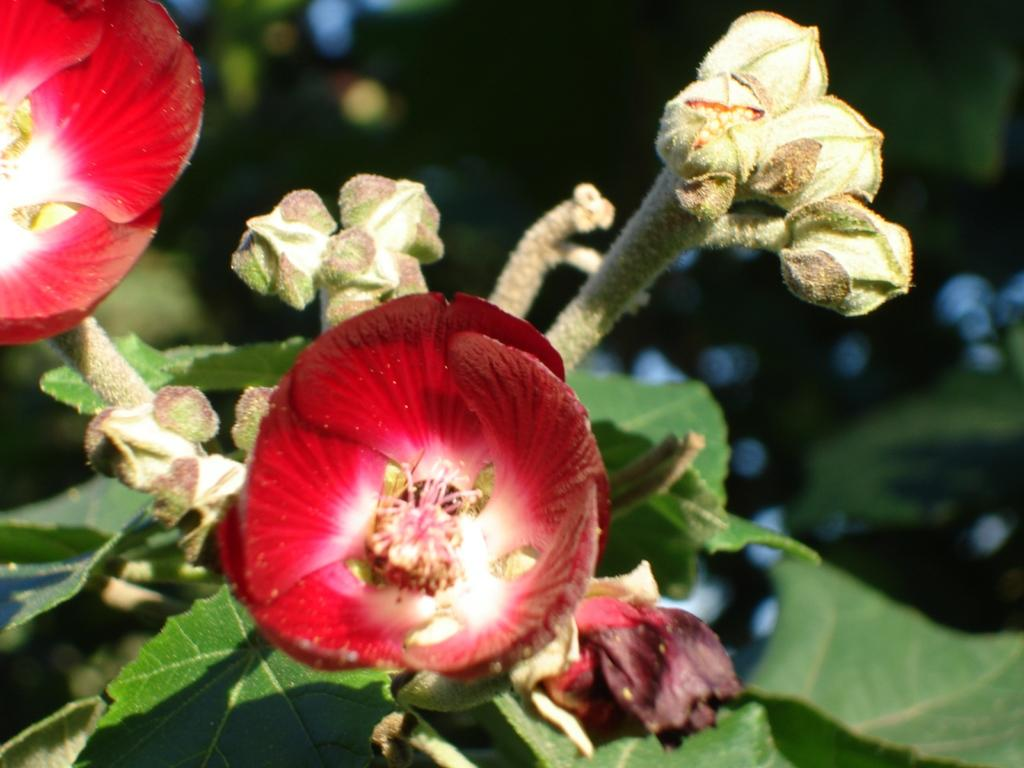What type of plants can be seen in the image? There are flowers, buds, and leaves in the image. Can you describe the stage of growth for the plants in the image? The plants in the image have both buds and flowers, indicating that they are in various stages of growth. What is the background of the image like? The background of the image is blurry. How many boys are playing the guitar in the image? There are no boys or guitars present in the image; it features plants with flowers, buds, and leaves. 